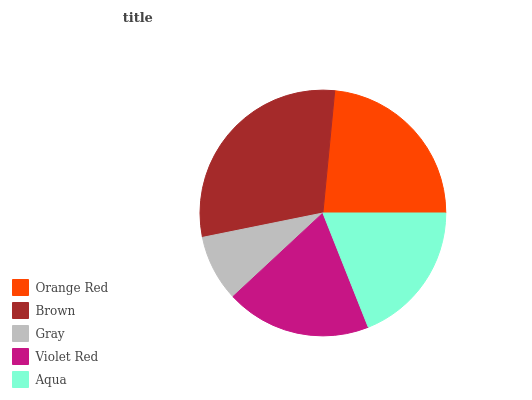Is Gray the minimum?
Answer yes or no. Yes. Is Brown the maximum?
Answer yes or no. Yes. Is Brown the minimum?
Answer yes or no. No. Is Gray the maximum?
Answer yes or no. No. Is Brown greater than Gray?
Answer yes or no. Yes. Is Gray less than Brown?
Answer yes or no. Yes. Is Gray greater than Brown?
Answer yes or no. No. Is Brown less than Gray?
Answer yes or no. No. Is Violet Red the high median?
Answer yes or no. Yes. Is Violet Red the low median?
Answer yes or no. Yes. Is Orange Red the high median?
Answer yes or no. No. Is Brown the low median?
Answer yes or no. No. 